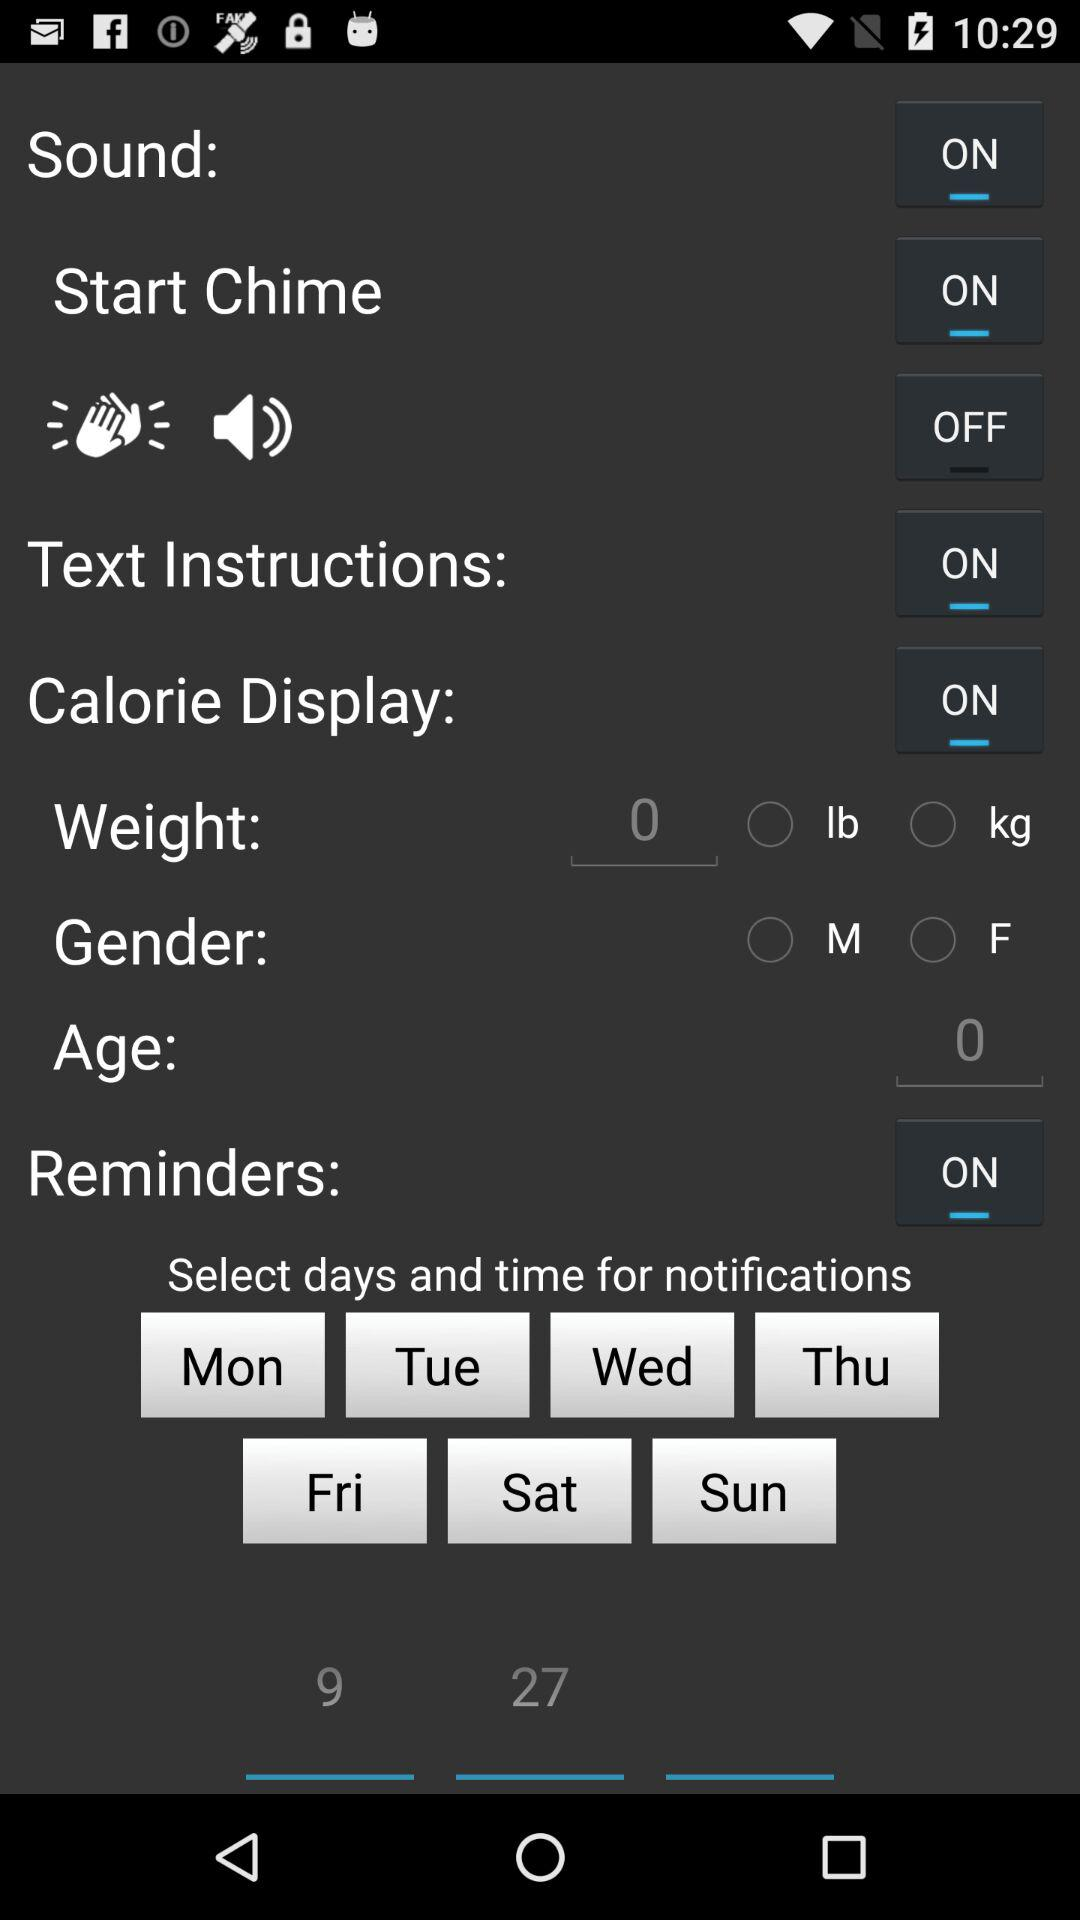What is the status of "Text Instructions"? The status is "on". 